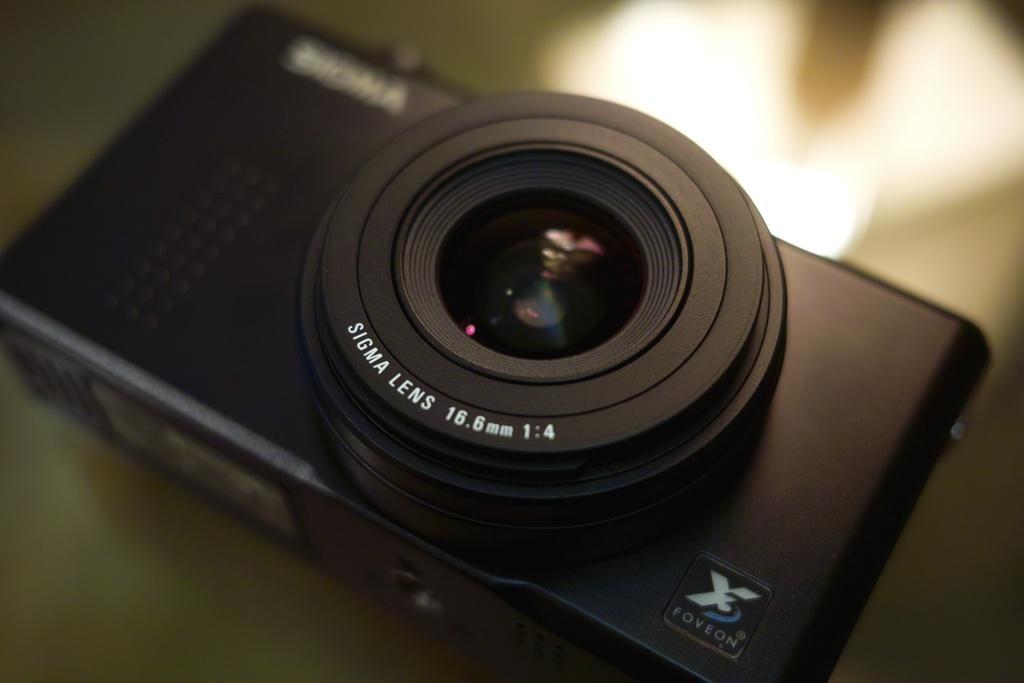What type of furniture is present in the image? There is a table in the image. What object is placed on the table? There is a black color camera on the table. What type of joke can be seen in the image? There is no joke present in the image; it features a table with a black color camera on it. 